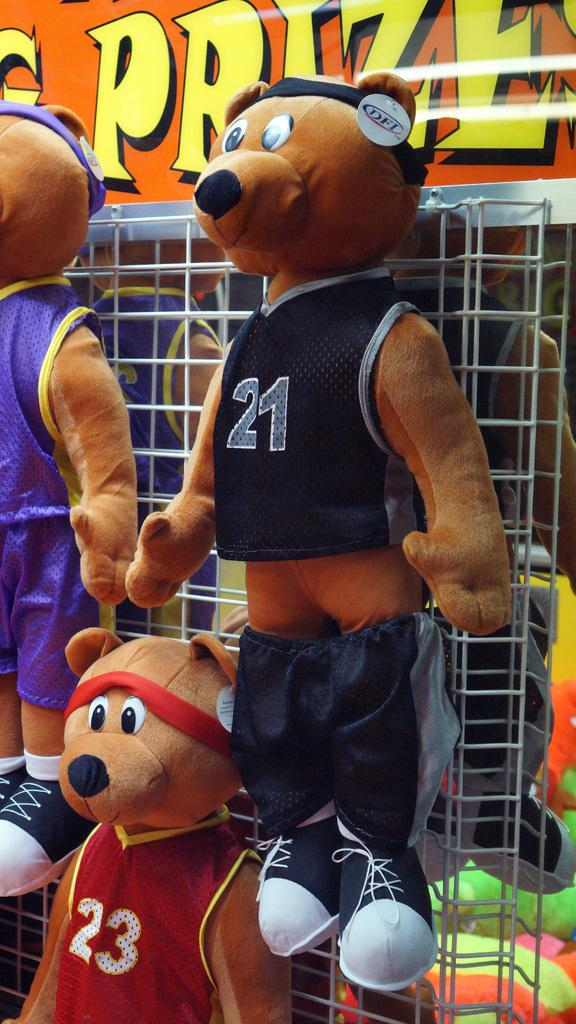<image>
Give a short and clear explanation of the subsequent image. A brown stuffed bear wears a blue jersey with number 21. 